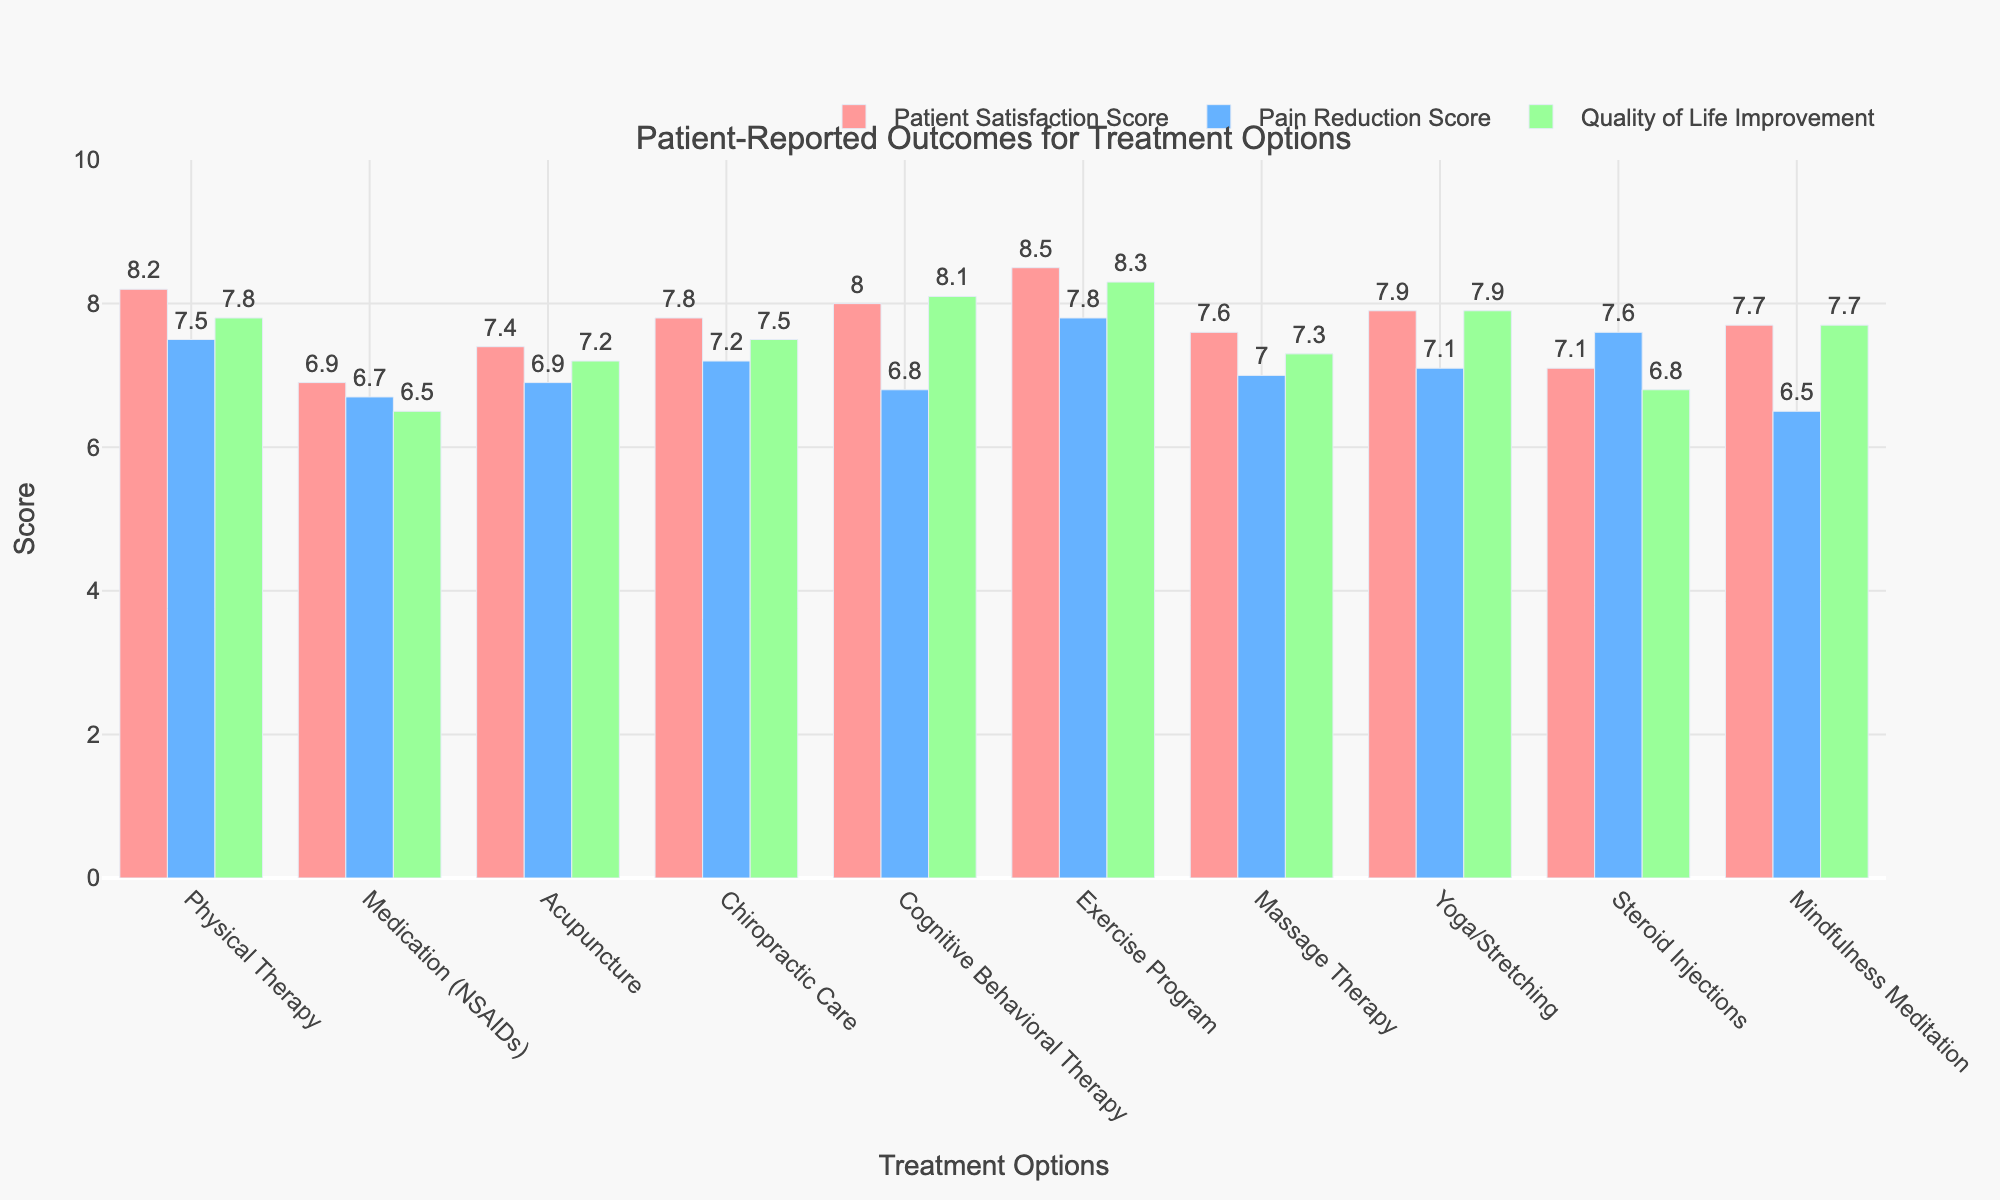Which treatment has the highest Patient Satisfaction Score? Look at the Patient Satisfaction Score bars and compare their heights to identify the highest one.
Answer: Exercise Program What is the difference in Pain Reduction Scores between Physical Therapy and Medication (NSAIDs)? Find the Pain Reduction Scores for Physical Therapy (7.5) and Medication (NSAIDs) (6.7) and subtract the latter from the former: 7.5 - 6.7.
Answer: 0.8 Which treatment option has the lowest Quality of Life Improvement score? Compare the Quality of Life Improvement scores and identify the smallest one.
Answer: Medication (NSAIDs) What is the average Patient Satisfaction Score for Acupuncture and Chiropractic Care? Find the Patient Satisfaction Scores for Acupuncture (7.4) and Chiropractic Care (7.8), then calculate the average: (7.4 + 7.8) / 2.
Answer: 7.6 Does Cognitive Behavioral Therapy have a higher Quality of Life Improvement score than Patient Satisfaction Score? Compare the Quality of Life Improvement score (8.1) to the Patient Satisfaction Score (8.0) for Cognitive Behavioral Therapy.
Answer: Yes Which three treatments provide the highest Pain Reduction Scores? Compare the Pain Reduction Scores of all treatments and list the three highest: Physical Therapy (7.5), Steroid Injections (7.6), and Exercise Program (7.8).
Answer: Exercise Program, Steroid Injections, Physical Therapy Across all treatments, what is the total sum of Quality of Life Improvement scores? Add the Quality of Life Improvement scores for all treatments: 7.8 + 6.5 + 7.2 + 7.5 + 8.1 + 8.3 + 7.3 + 7.9 + 6.8 + 7.7.
Answer: 75.1 Which treatment shows the smallest difference between Pain Reduction Score and Quality of Life Improvement score? Calculate the absolute differences between Pain Reduction Score and Quality of Life Improvement score for each treatment and identify the smallest difference: for example, 7.5 - 7.8 for Physical Therapy, 6.7 - 6.5 for Medication (NSAIDs), etc.
Answer: Medication (NSAIDs) Is the Patient Satisfaction Score for Yoga/Stretching higher or lower than that for Chiropractic Care? Compare the Patient Satisfaction Scores: Yoga/Stretching is 7.9 and Chiropractic Care is 7.8.
Answer: Higher What is the rank of Massage Therapy in terms of Patient Satisfaction Score among all treatments? Rank the treatments based on their Patient Satisfaction Scores and find the position of Massage Therapy (7.6).
Answer: 8th 